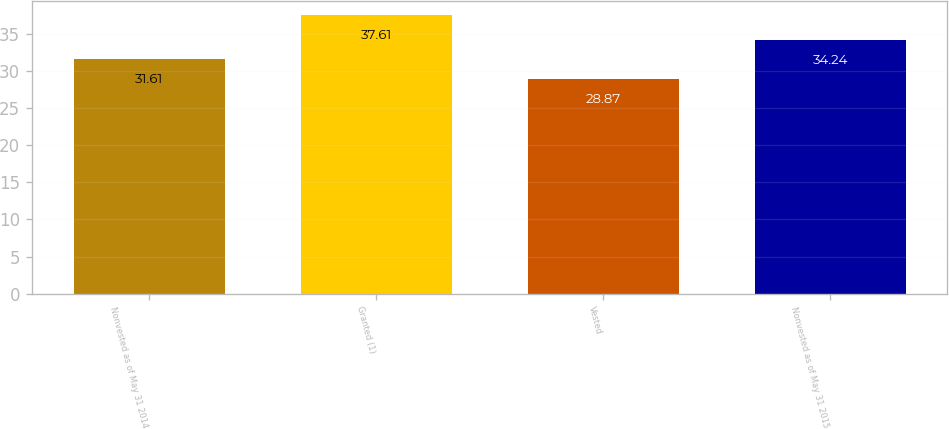Convert chart to OTSL. <chart><loc_0><loc_0><loc_500><loc_500><bar_chart><fcel>Nonvested as of May 31 2014<fcel>Granted (1)<fcel>Vested<fcel>Nonvested as of May 31 2015<nl><fcel>31.61<fcel>37.61<fcel>28.87<fcel>34.24<nl></chart> 